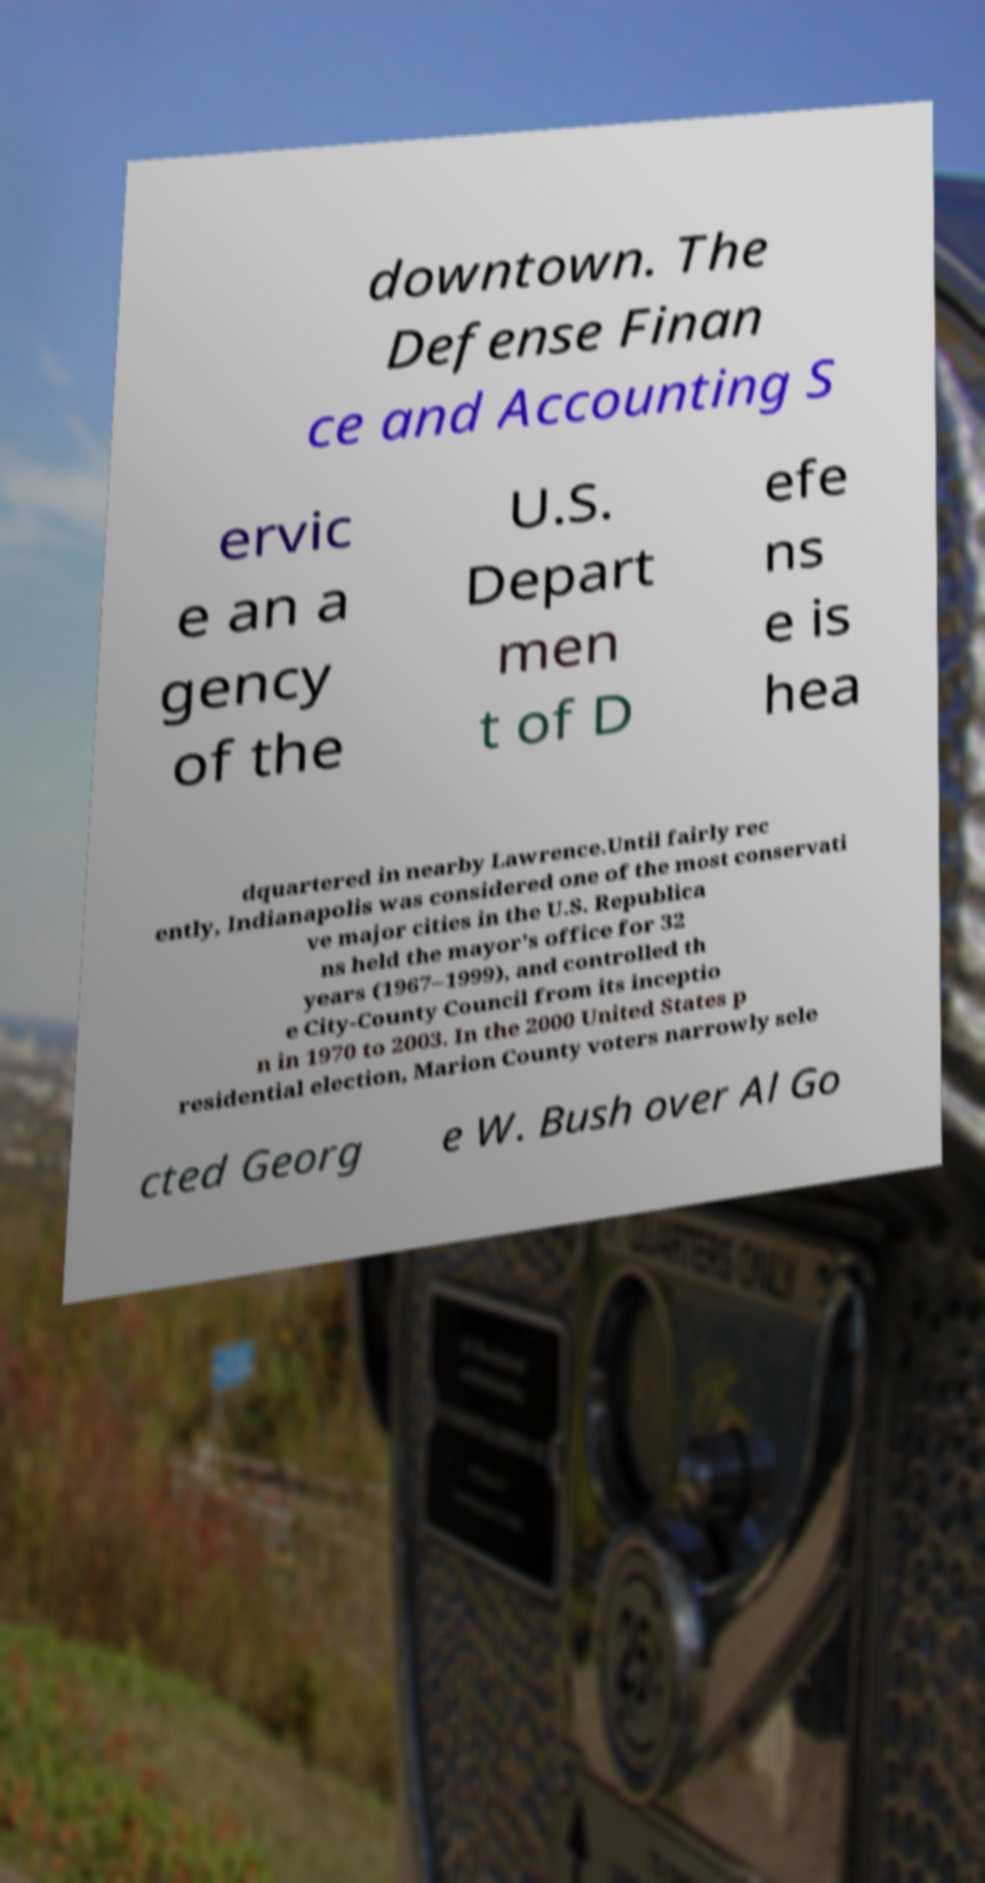What messages or text are displayed in this image? I need them in a readable, typed format. downtown. The Defense Finan ce and Accounting S ervic e an a gency of the U.S. Depart men t of D efe ns e is hea dquartered in nearby Lawrence.Until fairly rec ently, Indianapolis was considered one of the most conservati ve major cities in the U.S. Republica ns held the mayor's office for 32 years (1967–1999), and controlled th e City-County Council from its inceptio n in 1970 to 2003. In the 2000 United States p residential election, Marion County voters narrowly sele cted Georg e W. Bush over Al Go 